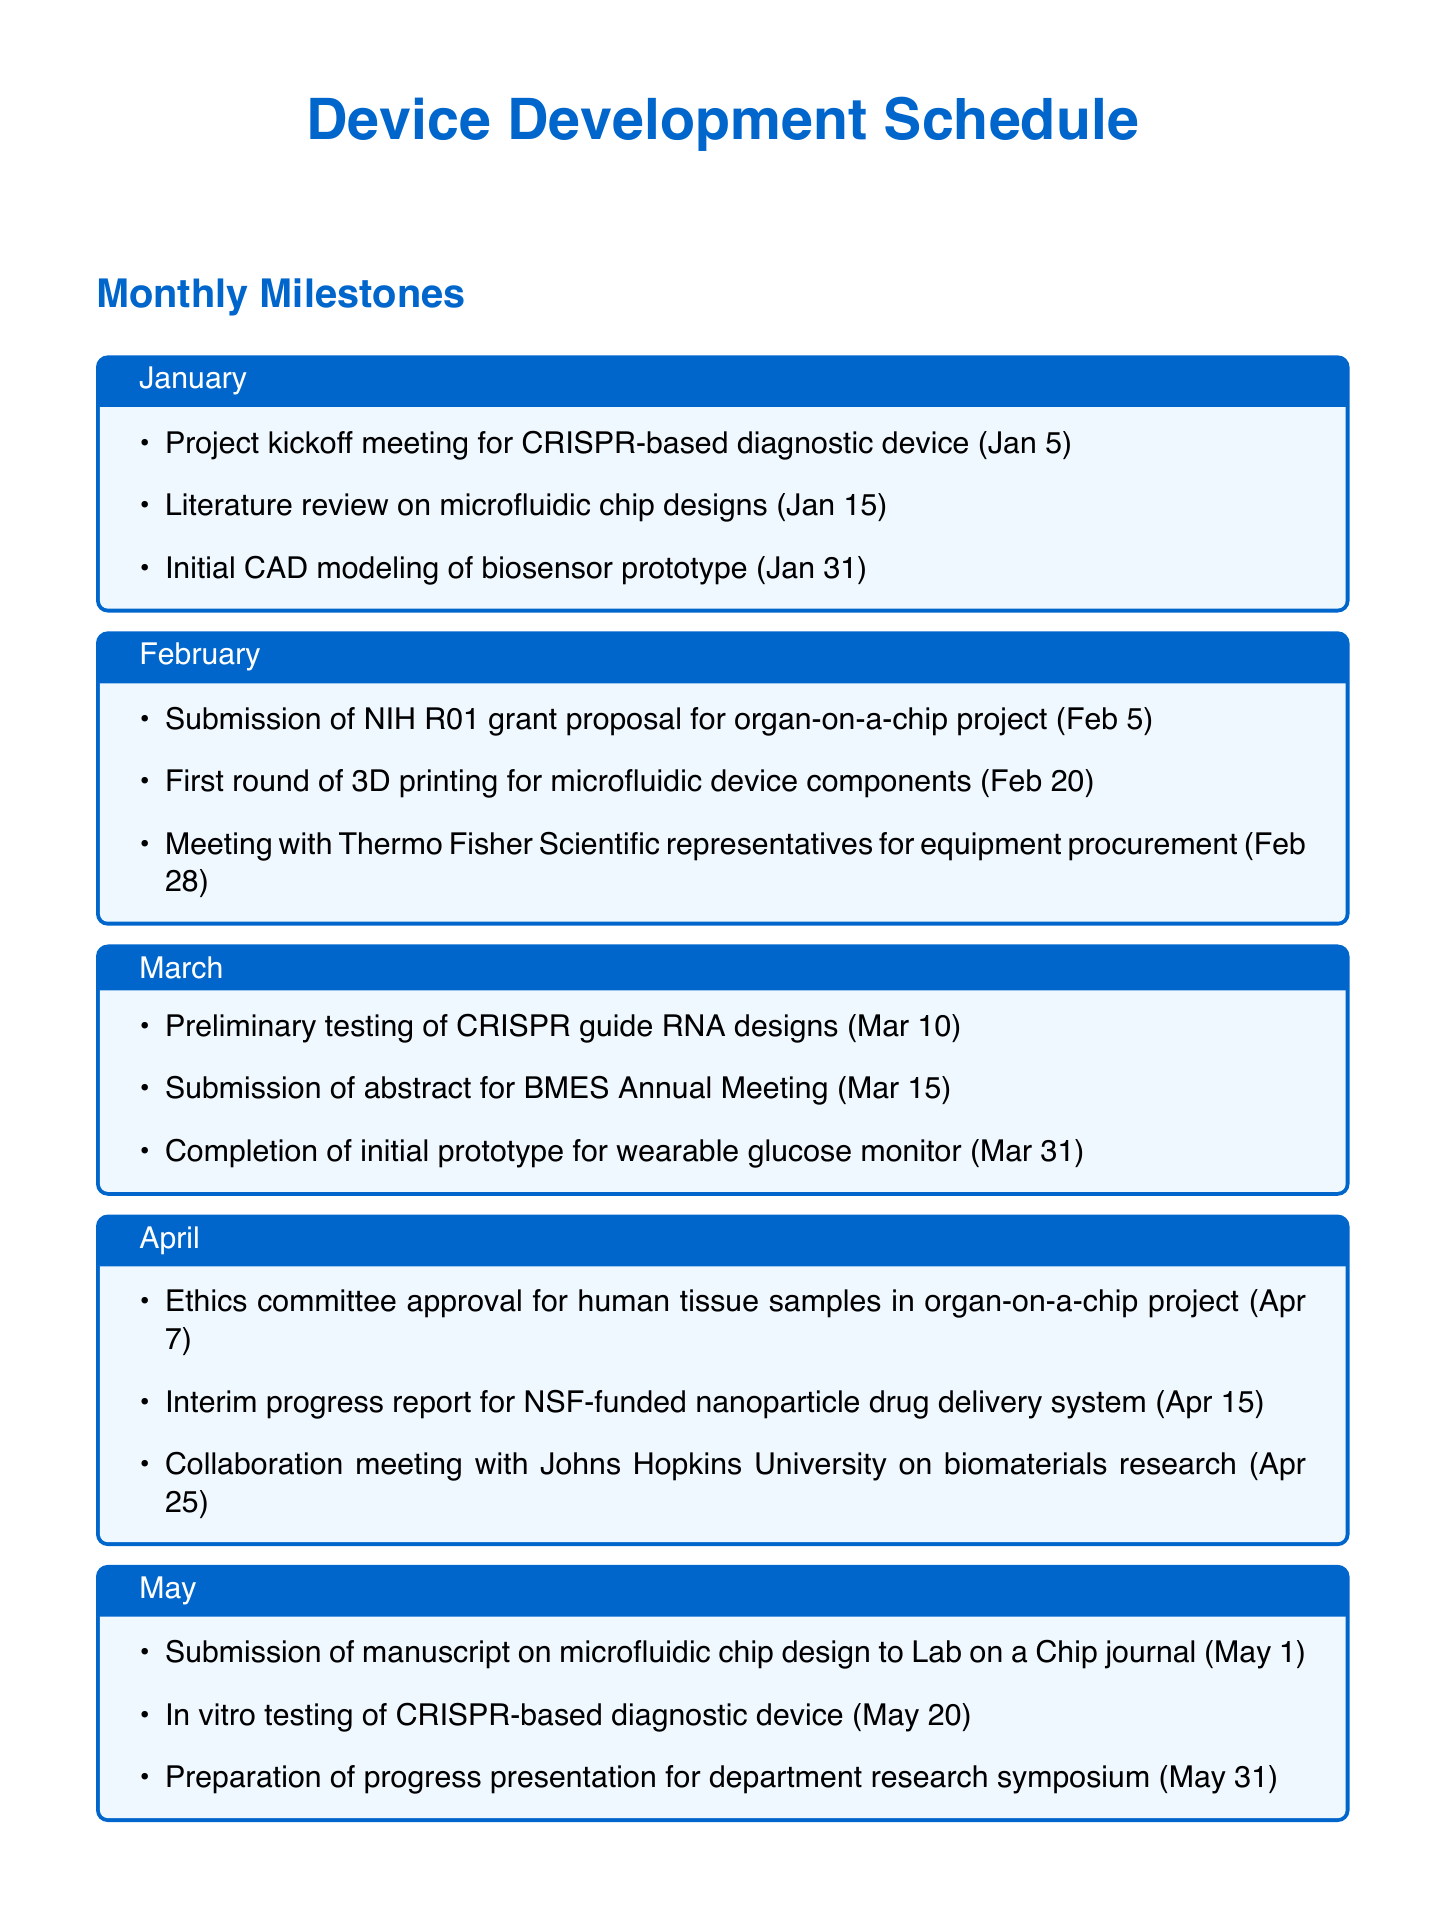what is the deadline for the project kickoff meeting? The deadline for the project kickoff meeting is listed in January's tasks.
Answer: January 5 which task is due on February 20? The task due on February 20 is referenced in February's milestones.
Answer: First round of 3D printing for microfluidic device components how many tasks are listed for March? The number of tasks for March can be counted from the tasks provided for that month.
Answer: 3 when is the ethics committee approval deadline? The deadline for ethics committee approval is specified under April's tasks.
Answer: April 7 which equipment requires bimonthly service? This information can be found in the equipment maintenance section, detailing maintenance schedules.
Answer: BD FACSAria III Flow Cytometer what frequency are the ongoing lab meetings held? The frequency is mentioned in the ongoing tasks section of the document.
Answer: Every Tuesday at 10:00 AM is there a task involving collaboration with Johns Hopkins University? Tasks are specified in April, indicating collaboration with an external university.
Answer: Yes how often is the advisory board meeting scheduled? The frequency of the advisory board meetings is outlined in the ongoing tasks section.
Answer: Quarterly 